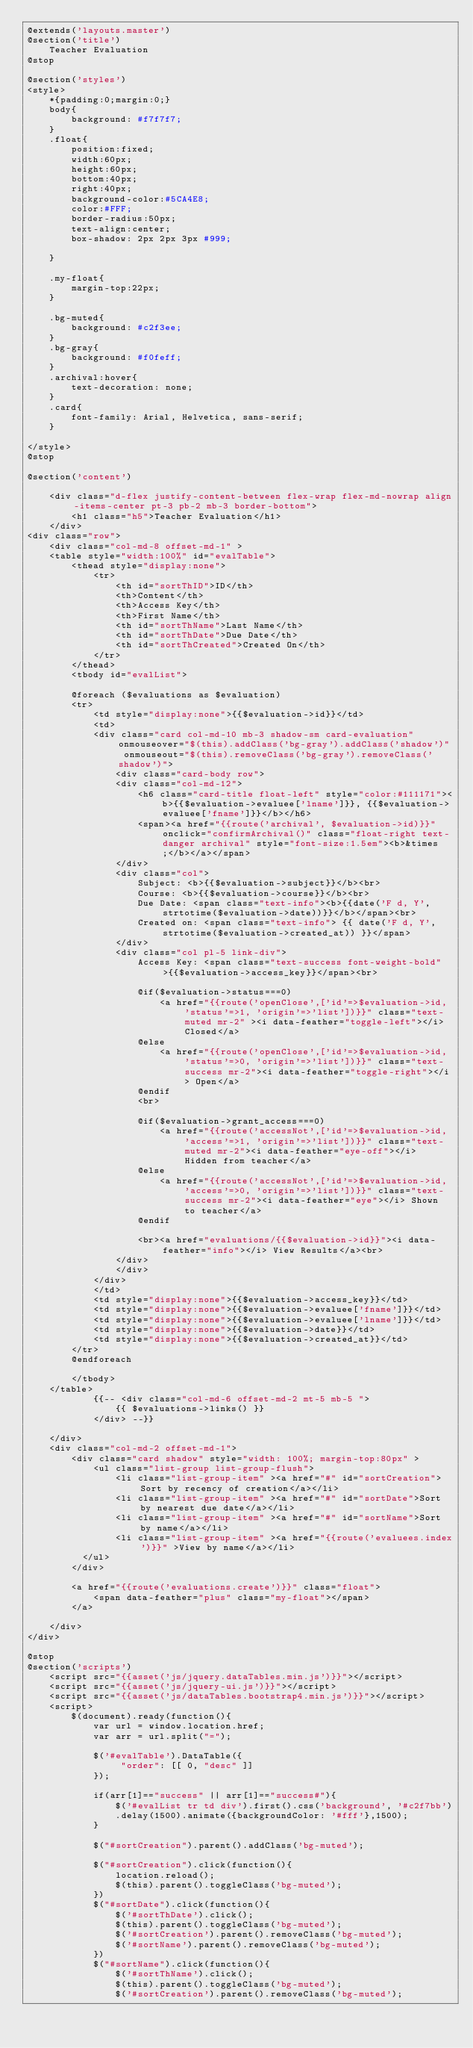<code> <loc_0><loc_0><loc_500><loc_500><_PHP_>@extends('layouts.master')
@section('title')
    Teacher Evaluation
@stop

@section('styles')
<style>
    *{padding:0;margin:0;}
    body{
        background: #f7f7f7;
    }
    .float{
        position:fixed;
        width:60px;
        height:60px;
        bottom:40px; 
        right:40px;
        background-color:#5CA4E8;
        color:#FFF;
        border-radius:50px;
        text-align:center;
        box-shadow: 2px 2px 3px #999;
        
    }

    .my-float{
        margin-top:22px;
    }

    .bg-muted{
        background: #c2f3ee;
    }
    .bg-gray{
        background: #f0feff;
    }
    .archival:hover{
        text-decoration: none;
    }
    .card{
        font-family: Arial, Helvetica, sans-serif;
    }

</style>
@stop

@section('content') 

    <div class="d-flex justify-content-between flex-wrap flex-md-nowrap align-items-center pt-3 pb-2 mb-3 border-bottom">
        <h1 class="h5">Teacher Evaluation</h1>
    </div>
<div class="row">   
    <div class="col-md-8 offset-md-1" >
    <table style="width:100%" id="evalTable">
        <thead style="display:none">
            <tr>
                <th id="sortThID">ID</th>
                <th>Content</th>
                <th>Access Key</th>
                <th>First Name</th>
                <th id="sortThName">Last Name</th>
                <th id="sortThDate">Due Date</th>
                <th id="sortThCreated">Created On</th>
            </tr>
        </thead>
        <tbody id="evalList">

        @foreach ($evaluations as $evaluation)
        <tr>
            <td style="display:none">{{$evaluation->id}}</td>
            <td>
            <div class="card col-md-10 mb-3 shadow-sm card-evaluation" onmouseover="$(this).addClass('bg-gray').addClass('shadow')" onmouseout="$(this).removeClass('bg-gray').removeClass('shadow')">
                <div class="card-body row">
                <div class="col-md-12">
                    <h6 class="card-title float-left" style="color:#111171"><b>{{$evaluation->evaluee['lname']}}, {{$evaluation->evaluee['fname']}}</b></h6>
                    <span><a href="{{route('archival', $evaluation->id)}}" onclick="confirmArchival()" class="float-right text-danger archival" style="font-size:1.5em"><b>&times;</b></a></span>
                </div>
                <div class="col">
                    Subject: <b>{{$evaluation->subject}}</b><br>
                    Course: <b>{{$evaluation->course}}</b><br>
                    Due Date: <span class="text-info"><b>{{date('F d, Y', strtotime($evaluation->date))}}</b></span><br>
                    Created on: <span class="text-info"> {{ date('F d, Y', strtotime($evaluation->created_at)) }}</span>
                </div>
                <div class="col pl-5 link-div">
                    Access Key: <span class="text-success font-weight-bold">{{$evaluation->access_key}}</span><br>
                    
                    @if($evaluation->status===0)
                        <a href="{{route('openClose',['id'=>$evaluation->id, 'status'=>1, 'origin'=>'list'])}}" class="text-muted mr-2" ><i data-feather="toggle-left"></i> Closed</a>
                    @else 
                        <a href="{{route('openClose',['id'=>$evaluation->id, 'status'=>0, 'origin'=>'list'])}}" class="text-success mr-2"><i data-feather="toggle-right"></i> Open</a>
                    @endif
                    <br>
                    
                    @if($evaluation->grant_access===0)
                        <a href="{{route('accessNot',['id'=>$evaluation->id, 'access'=>1, 'origin'=>'list'])}}" class="text-muted mr-2"><i data-feather="eye-off"></i> Hidden from teacher</a>
                    @else 
                        <a href="{{route('accessNot',['id'=>$evaluation->id, 'access'=>0, 'origin'=>'list'])}}" class="text-success mr-2"><i data-feather="eye"></i> Shown to teacher</a>
                    @endif
                
                    <br><a href="evaluations/{{$evaluation->id}}"><i data-feather="info"></i> View Results</a><br>
                </div>
                </div>
            </div>
            </td>
            <td style="display:none">{{$evaluation->access_key}}</td>
            <td style="display:none">{{$evaluation->evaluee['fname']}}</td>
            <td style="display:none">{{$evaluation->evaluee['lname']}}</td>
            <td style="display:none">{{$evaluation->date}}</td>
            <td style="display:none">{{$evaluation->created_at}}</td>
        </tr>
        @endforeach
 
        </tbody>
    </table>
            {{-- <div class="col-md-6 offset-md-2 mt-5 mb-5 ">
                {{ $evaluations->links() }}
            </div> --}}
        
    </div>
    <div class="col-md-2 offset-md-1">
        <div class="card shadow" style="width: 100%; margin-top:80px" >
            <ul class="list-group list-group-flush">
                <li class="list-group-item" ><a href="#" id="sortCreation">Sort by recency of creation</a></li>
                <li class="list-group-item" ><a href="#" id="sortDate">Sort by nearest due date</a></li>
                <li class="list-group-item" ><a href="#" id="sortName">Sort by name</a></li>
                <li class="list-group-item" ><a href="{{route('evaluees.index')}}" >View by name</a></li>
          </ul>
        </div>

        <a href="{{route('evaluations.create')}}" class="float">
            <span data-feather="plus" class="my-float"></span>
        </a>

    </div>
</div>
 
@stop
@section('scripts')
    <script src="{{asset('js/jquery.dataTables.min.js')}}"></script>
    <script src="{{asset('js/jquery-ui.js')}}"></script>
    <script src="{{asset('js/dataTables.bootstrap4.min.js')}}"></script>
    <script>
        $(document).ready(function(){
            var url = window.location.href;
            var arr = url.split("=");

            $('#evalTable').DataTable({
                 "order": [[ 0, "desc" ]]
            });

            if(arr[1]=="success" || arr[1]=="success#"){
                $('#evalList tr td div').first().css('background', '#c2f7bb')
                .delay(1500).animate({backgroundColor: '#fff'},1500);
            }

            $("#sortCreation").parent().addClass('bg-muted');

            $("#sortCreation").click(function(){
                location.reload();
                $(this).parent().toggleClass('bg-muted');
            })
            $("#sortDate").click(function(){
                $('#sortThDate').click();
                $(this).parent().toggleClass('bg-muted');
                $('#sortCreation').parent().removeClass('bg-muted');
                $('#sortName').parent().removeClass('bg-muted');
            })
            $("#sortName").click(function(){
                $('#sortThName').click();
                $(this).parent().toggleClass('bg-muted');
                $('#sortCreation').parent().removeClass('bg-muted');</code> 